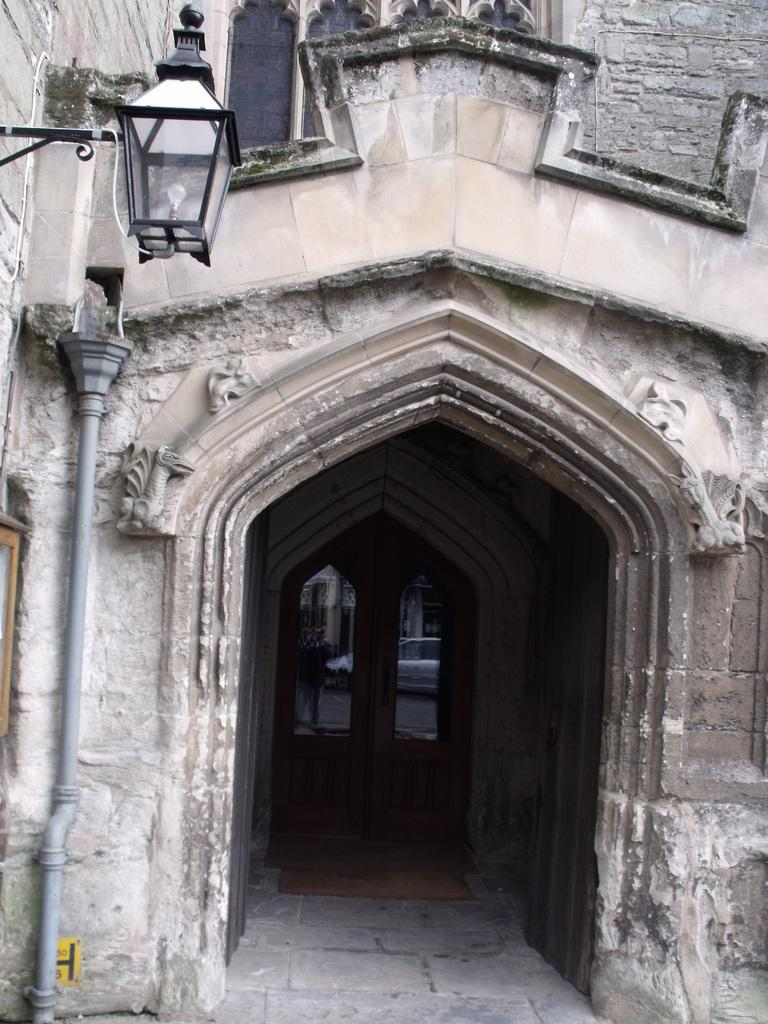What type of building is in the image? There is an old building in the image. What material is used for the door of the building? The building has a wooden door. What lighting fixture is attached to the wall of the building? There is a lamp on the wall of the building. What else can be seen beside the lamp on the wall? There is a pipe beside the lamp on the wall. What type of bit does the girl use to control her partner in the image? There is no girl or partner present in the image; it only features an old building with a wooden door, a lamp, and a pipe. 